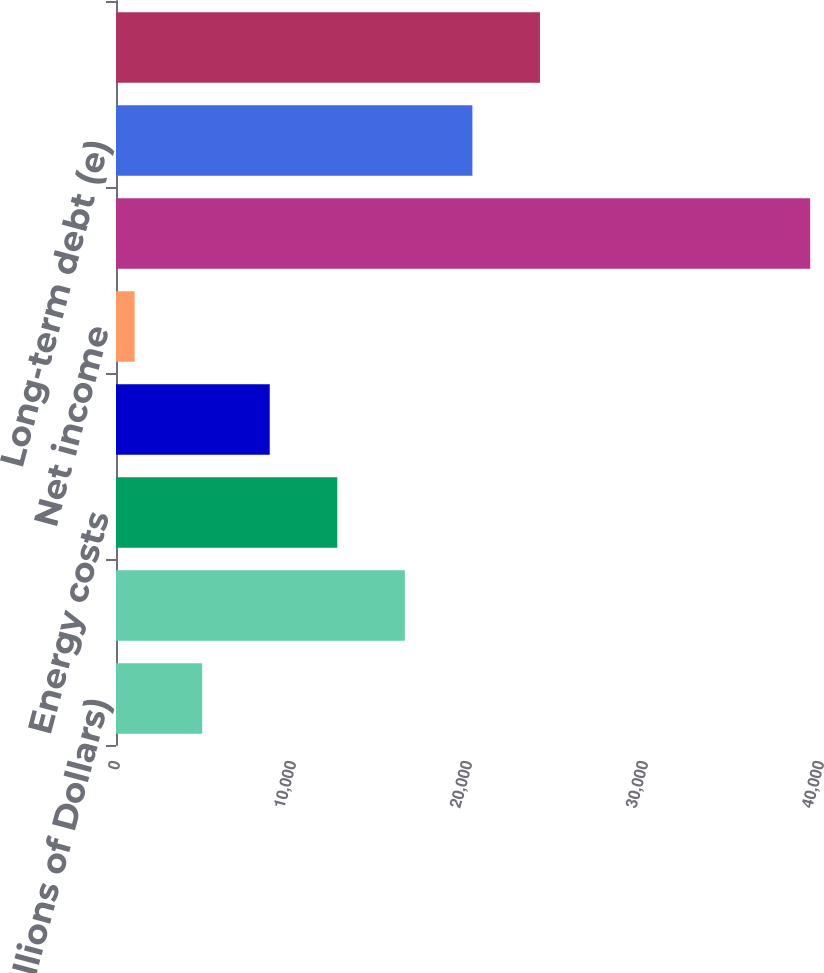<chart> <loc_0><loc_0><loc_500><loc_500><bar_chart><fcel>(Millions of Dollars)<fcel>Operating revenues<fcel>Energy costs<fcel>Operating income<fcel>Net income<fcel>Total assets (e)(f)<fcel>Long-term debt (e)<fcel>Shareholder's equity<nl><fcel>4896.5<fcel>16412<fcel>12573.5<fcel>8735<fcel>1058<fcel>39443<fcel>20250.5<fcel>24089<nl></chart> 